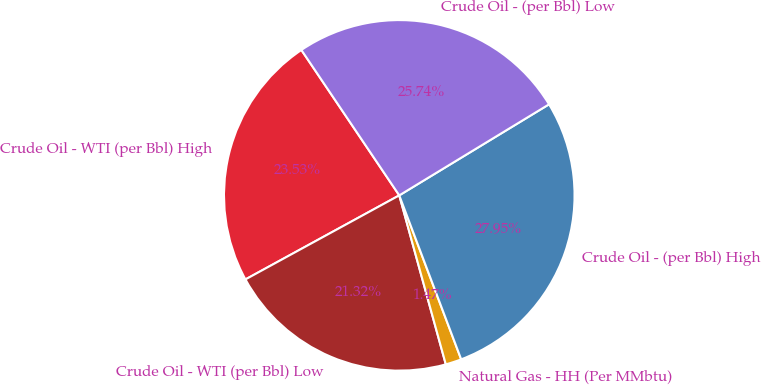<chart> <loc_0><loc_0><loc_500><loc_500><pie_chart><fcel>Crude Oil - WTI (per Bbl) High<fcel>Crude Oil - WTI (per Bbl) Low<fcel>Natural Gas - HH (Per MMbtu)<fcel>Crude Oil - (per Bbl) High<fcel>Crude Oil - (per Bbl) Low<nl><fcel>23.53%<fcel>21.32%<fcel>1.47%<fcel>27.95%<fcel>25.74%<nl></chart> 